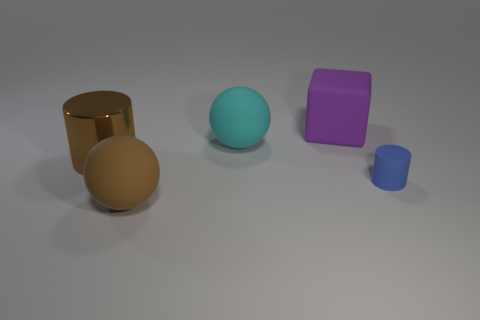Add 3 big matte spheres. How many objects exist? 8 Subtract all spheres. How many objects are left? 3 Subtract all brown spheres. How many spheres are left? 1 Subtract 0 red cubes. How many objects are left? 5 Subtract 1 balls. How many balls are left? 1 Subtract all brown cylinders. Subtract all yellow balls. How many cylinders are left? 1 Subtract all yellow balls. How many blue cylinders are left? 1 Subtract all purple matte cubes. Subtract all blocks. How many objects are left? 3 Add 1 rubber cylinders. How many rubber cylinders are left? 2 Add 4 small cyan matte blocks. How many small cyan matte blocks exist? 4 